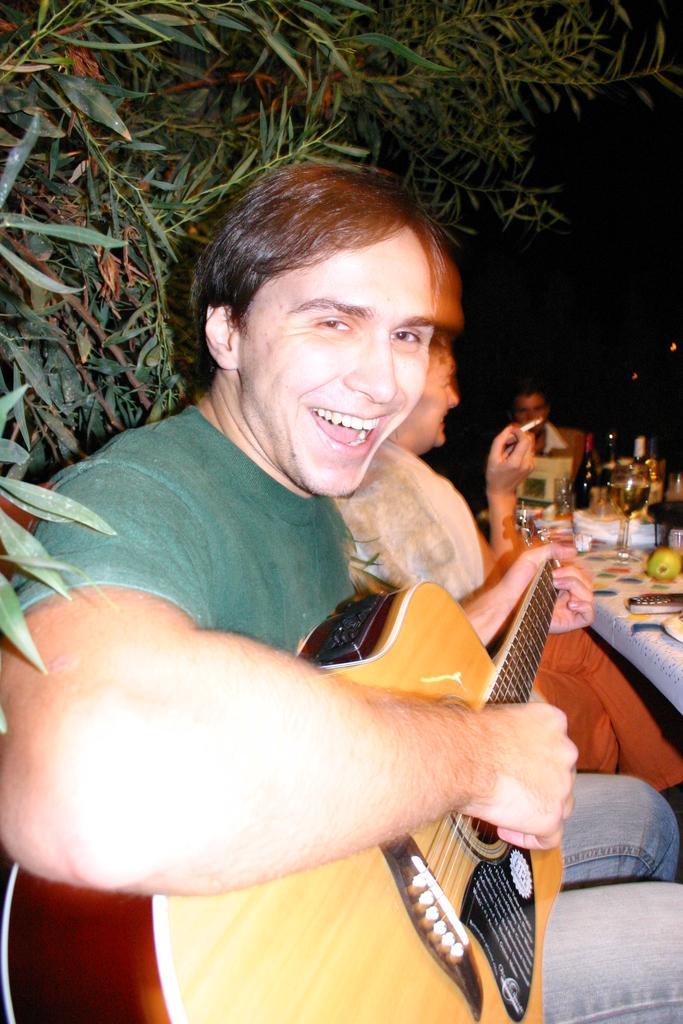In one or two sentences, can you explain what this image depicts? A man is sitting and holding a guitar he is smiling behind him there are trees. 